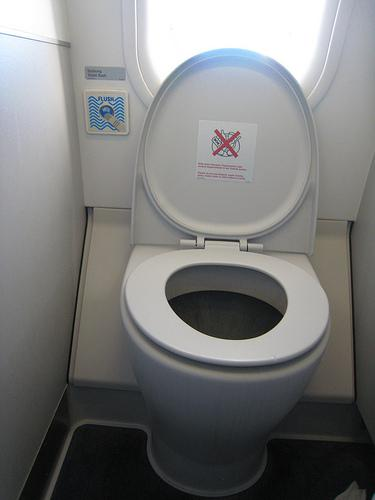Question: how do you flush it?
Choices:
A. Button.
B. Wave your hand in front of it.
C. With a remote control.
D. I push the button in the kitchen.
Answer with the letter. Answer: A Question: what happens to the matter?
Choices:
A. It lives under the sink.
B. It gets recycled.
C. It is eaaten by snails.
D. Flies out of the plane.
Answer with the letter. Answer: D Question: where is this located?
Choices:
A. Mall.
B. North Pole.
C. Airplane.
D. On the right side of the road.
Answer with the letter. Answer: C Question: what do you use it for?
Choices:
A. I wear it.
B. Bathroom services.
C. Cleaning the basement.
D. Exercising.
Answer with the letter. Answer: B Question: what do you call it?
Choices:
A. A table.
B. Toilet.
C. A lanyard.
D. I call it Sam.
Answer with the letter. Answer: B 